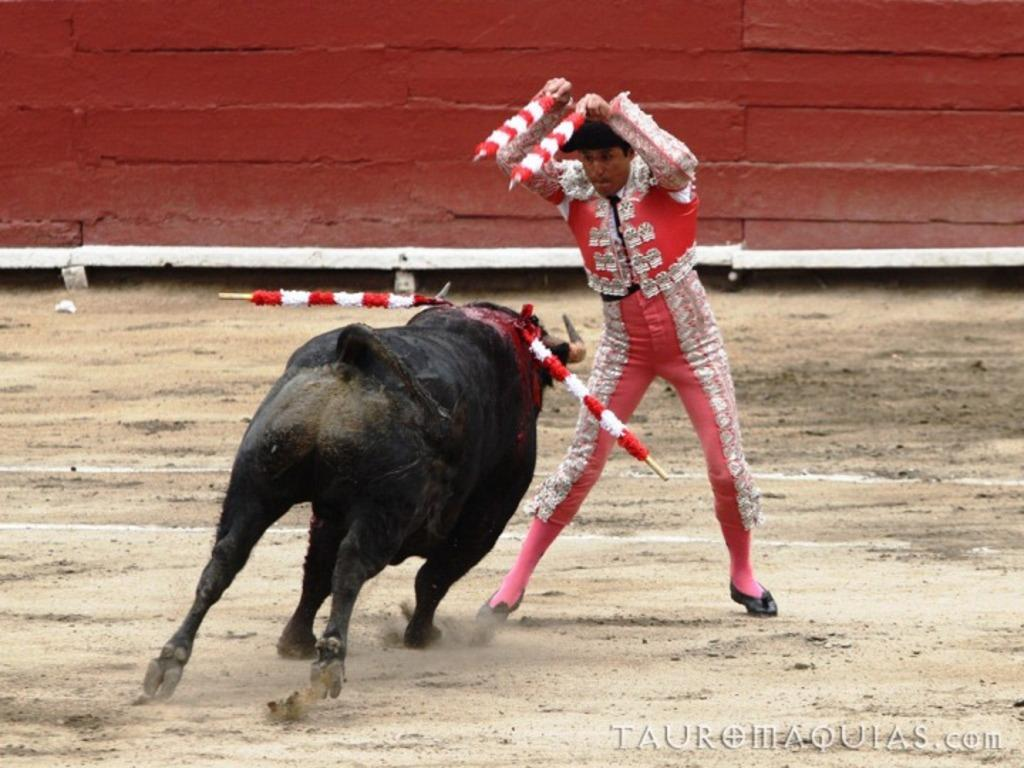What is the man in the image doing? The man in the image is in motion. What is the man holding in the image? The man is holding objects. What animal is in front of the man in the image? There is a bull in front of the man in the image. What can be seen in the background of the image? There is a wall in the background of the image. What additional feature can be observed on the right side of the image? There is a watermark on the right side of the image. How many boys are dancing to the rhythm in the image? There are no boys or dancing in the image; it features a man in motion with a bull in front of him. 